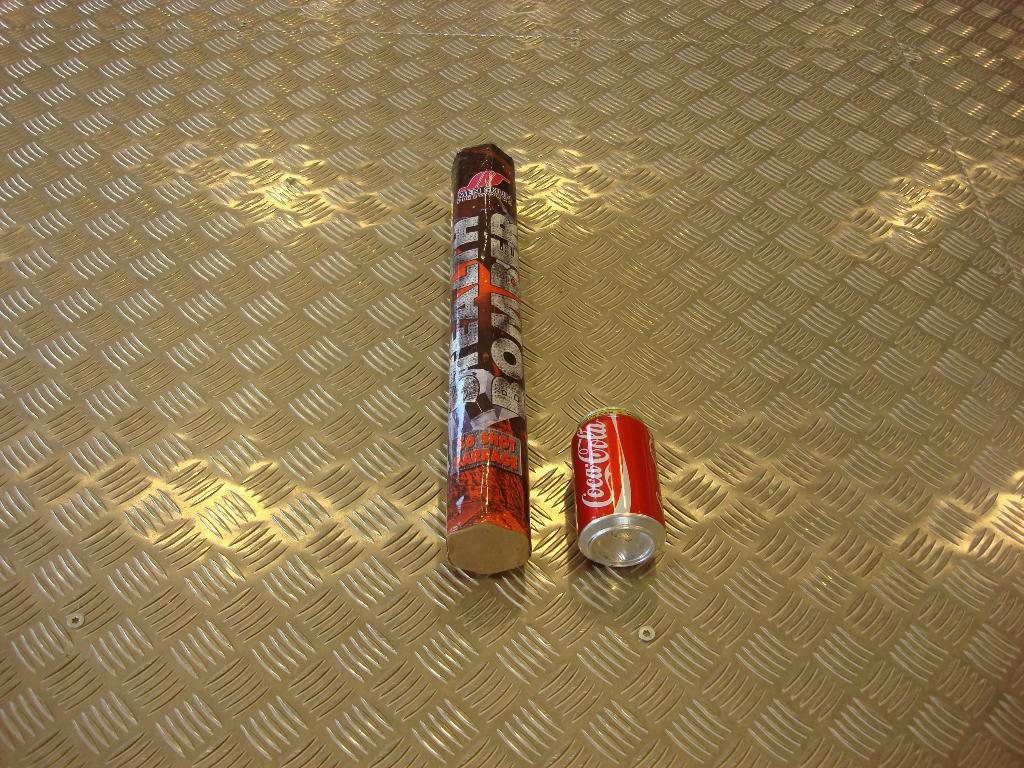<image>
Present a compact description of the photo's key features. A coca-cola can lays next to a stealth bomber package. 